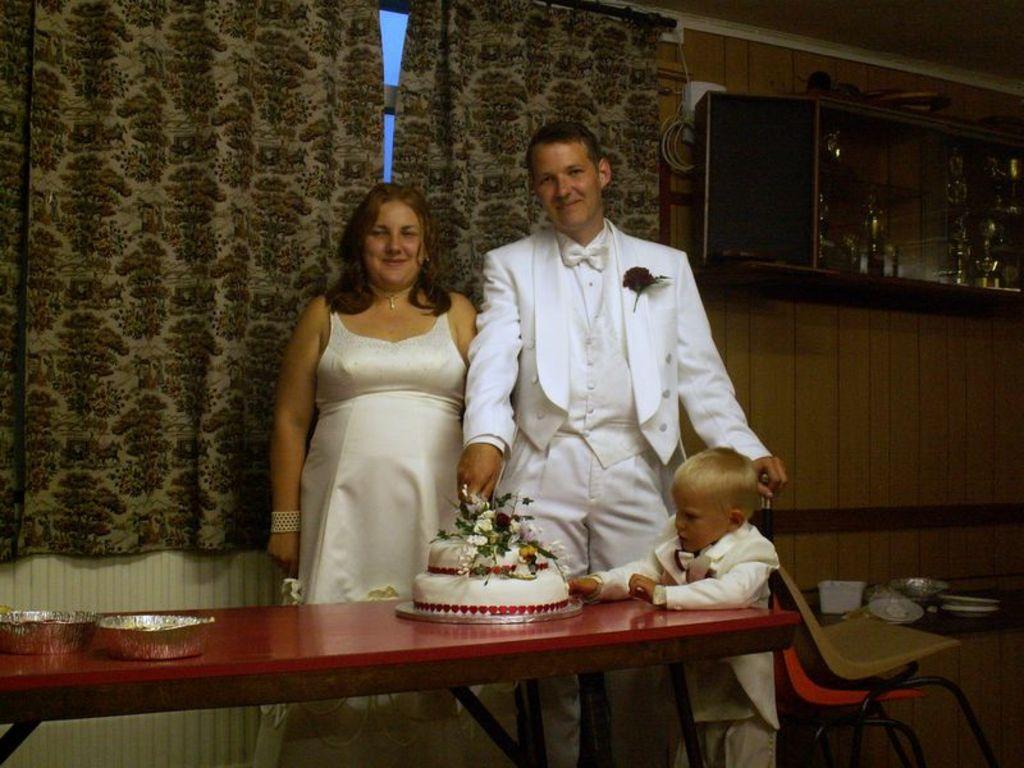Can you describe this image briefly? On the table bowl and cake is present and near people are standing,in back we have curtains,shelf and beside there are chairs. 